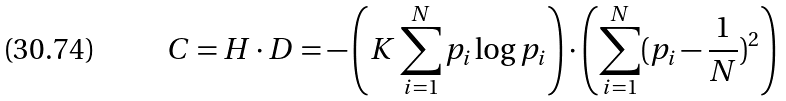<formula> <loc_0><loc_0><loc_500><loc_500>C = H \cdot D = - \left ( K \sum _ { i = 1 } ^ { N } p _ { i } \log p _ { i } \right ) \cdot \left ( \sum _ { i = 1 } ^ { N } ( p _ { i } - \frac { 1 } { N } ) ^ { 2 } \right )</formula> 